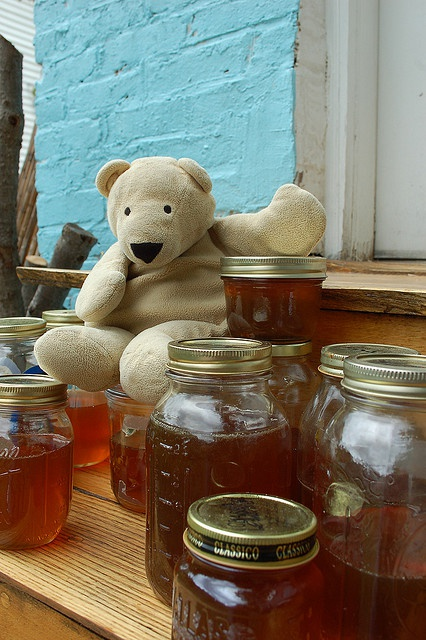Describe the objects in this image and their specific colors. I can see teddy bear in lightgray, tan, olive, and beige tones, bottle in lightgray, maroon, and gray tones, bottle in lightgray, maroon, olive, and gray tones, bottle in lightgray, maroon, black, olive, and gray tones, and bottle in lightgray, maroon, and gray tones in this image. 